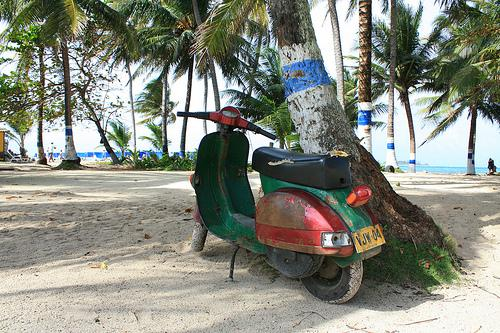Question: where was this picture taken?
Choices:
A. The lake.
B. A beach.
C. A graduation.
D. Wedding.
Answer with the letter. Answer: B Question: what kind of tree is it leaning on?
Choices:
A. Oak tree.
B. Palm tree.
C. Walnut tree.
D. Apple tree.
Answer with the letter. Answer: B 